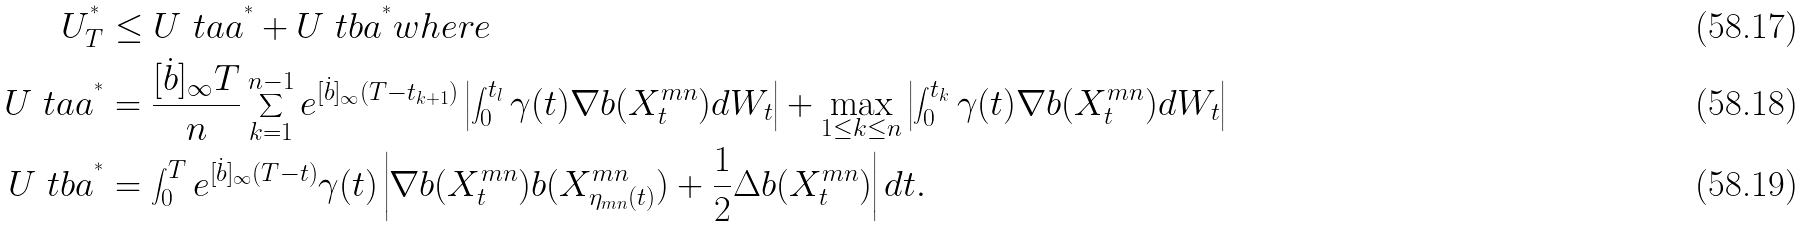Convert formula to latex. <formula><loc_0><loc_0><loc_500><loc_500>U ^ { ^ { * } } _ { T } & \leq U \ t a a ^ { ^ { * } } + U \ t b a ^ { ^ { * } } w h e r e \\ U \ t a a ^ { ^ { * } } & = \frac { [ \dot { b } ] _ { \infty } T } { n } \sum _ { k = 1 } ^ { n - 1 } e ^ { [ \dot { b } ] _ { \infty } ( T - t _ { k + 1 } ) } \left | \int _ { 0 } ^ { t _ { l } } \gamma ( t ) \nabla b ( X ^ { m n } _ { t } ) d W _ { t } \right | + \max _ { 1 \leq k \leq n } \left | \int _ { 0 } ^ { t _ { k } } \gamma ( t ) \nabla b ( X ^ { m n } _ { t } ) d W _ { t } \right | \\ U \ t b a ^ { ^ { * } } & = \int _ { 0 } ^ { T } e ^ { [ \dot { b } ] _ { \infty } ( T - t ) } \gamma ( t ) \left | \nabla b ( X ^ { m n } _ { t } ) b ( X ^ { m n } _ { \eta _ { m n } ( t ) } ) + \frac { 1 } { 2 } \Delta b ( X ^ { m n } _ { t } ) \right | d t .</formula> 